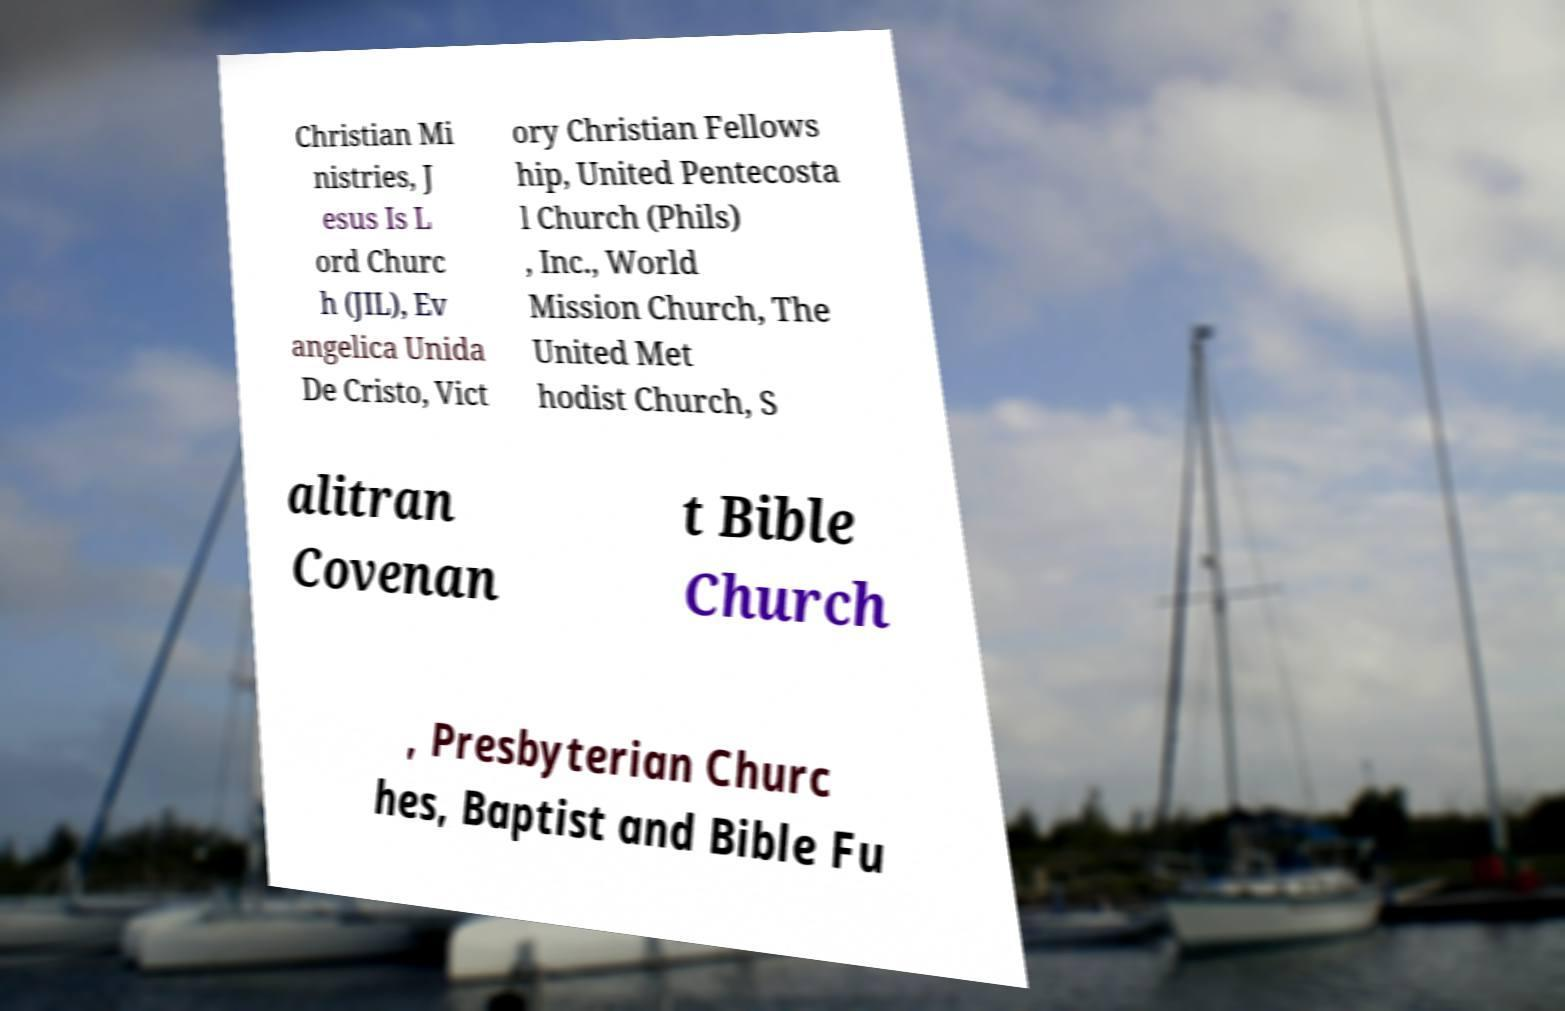There's text embedded in this image that I need extracted. Can you transcribe it verbatim? Christian Mi nistries, J esus Is L ord Churc h (JIL), Ev angelica Unida De Cristo, Vict ory Christian Fellows hip, United Pentecosta l Church (Phils) , Inc., World Mission Church, The United Met hodist Church, S alitran Covenan t Bible Church , Presbyterian Churc hes, Baptist and Bible Fu 